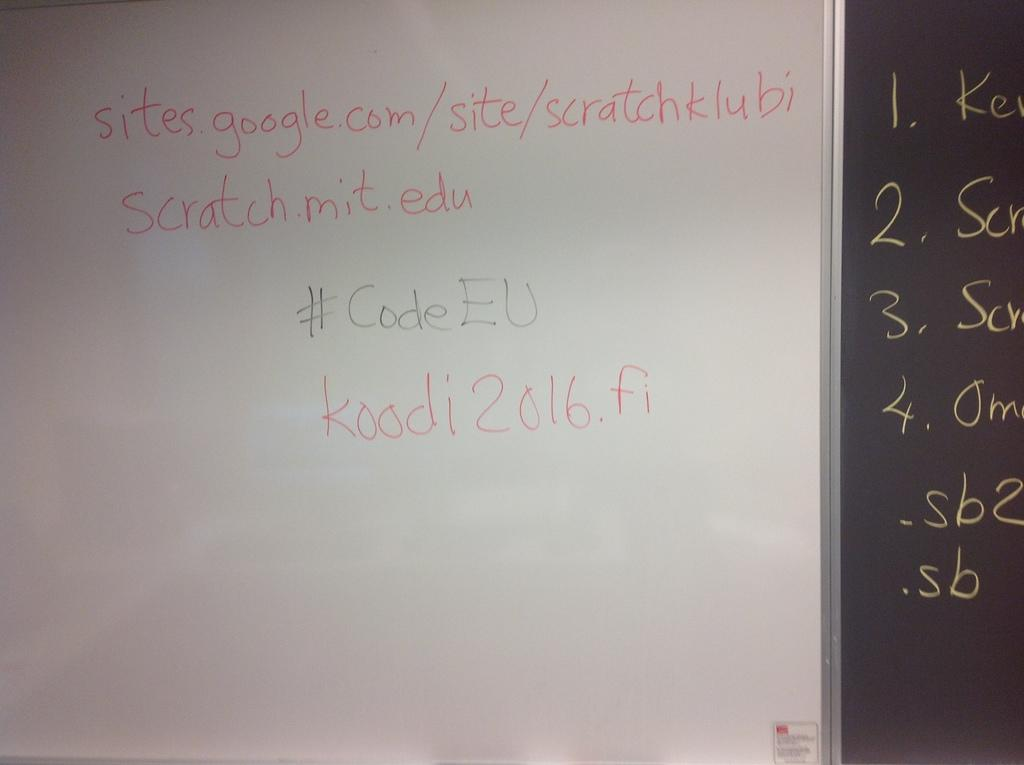<image>
Write a terse but informative summary of the picture. A whiteboard with a link to a google site written on it. 